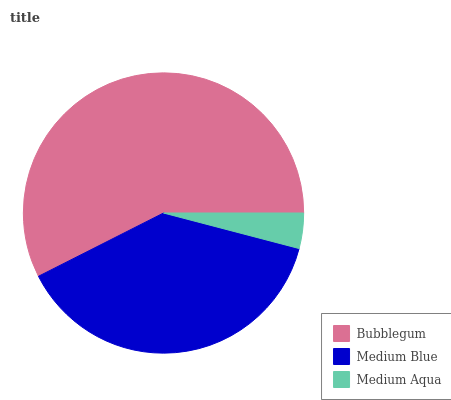Is Medium Aqua the minimum?
Answer yes or no. Yes. Is Bubblegum the maximum?
Answer yes or no. Yes. Is Medium Blue the minimum?
Answer yes or no. No. Is Medium Blue the maximum?
Answer yes or no. No. Is Bubblegum greater than Medium Blue?
Answer yes or no. Yes. Is Medium Blue less than Bubblegum?
Answer yes or no. Yes. Is Medium Blue greater than Bubblegum?
Answer yes or no. No. Is Bubblegum less than Medium Blue?
Answer yes or no. No. Is Medium Blue the high median?
Answer yes or no. Yes. Is Medium Blue the low median?
Answer yes or no. Yes. Is Medium Aqua the high median?
Answer yes or no. No. Is Medium Aqua the low median?
Answer yes or no. No. 